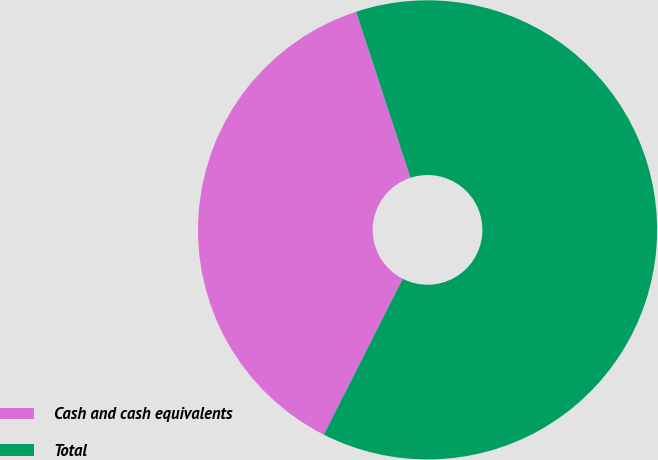Convert chart to OTSL. <chart><loc_0><loc_0><loc_500><loc_500><pie_chart><fcel>Cash and cash equivalents<fcel>Total<nl><fcel>37.5%<fcel>62.5%<nl></chart> 